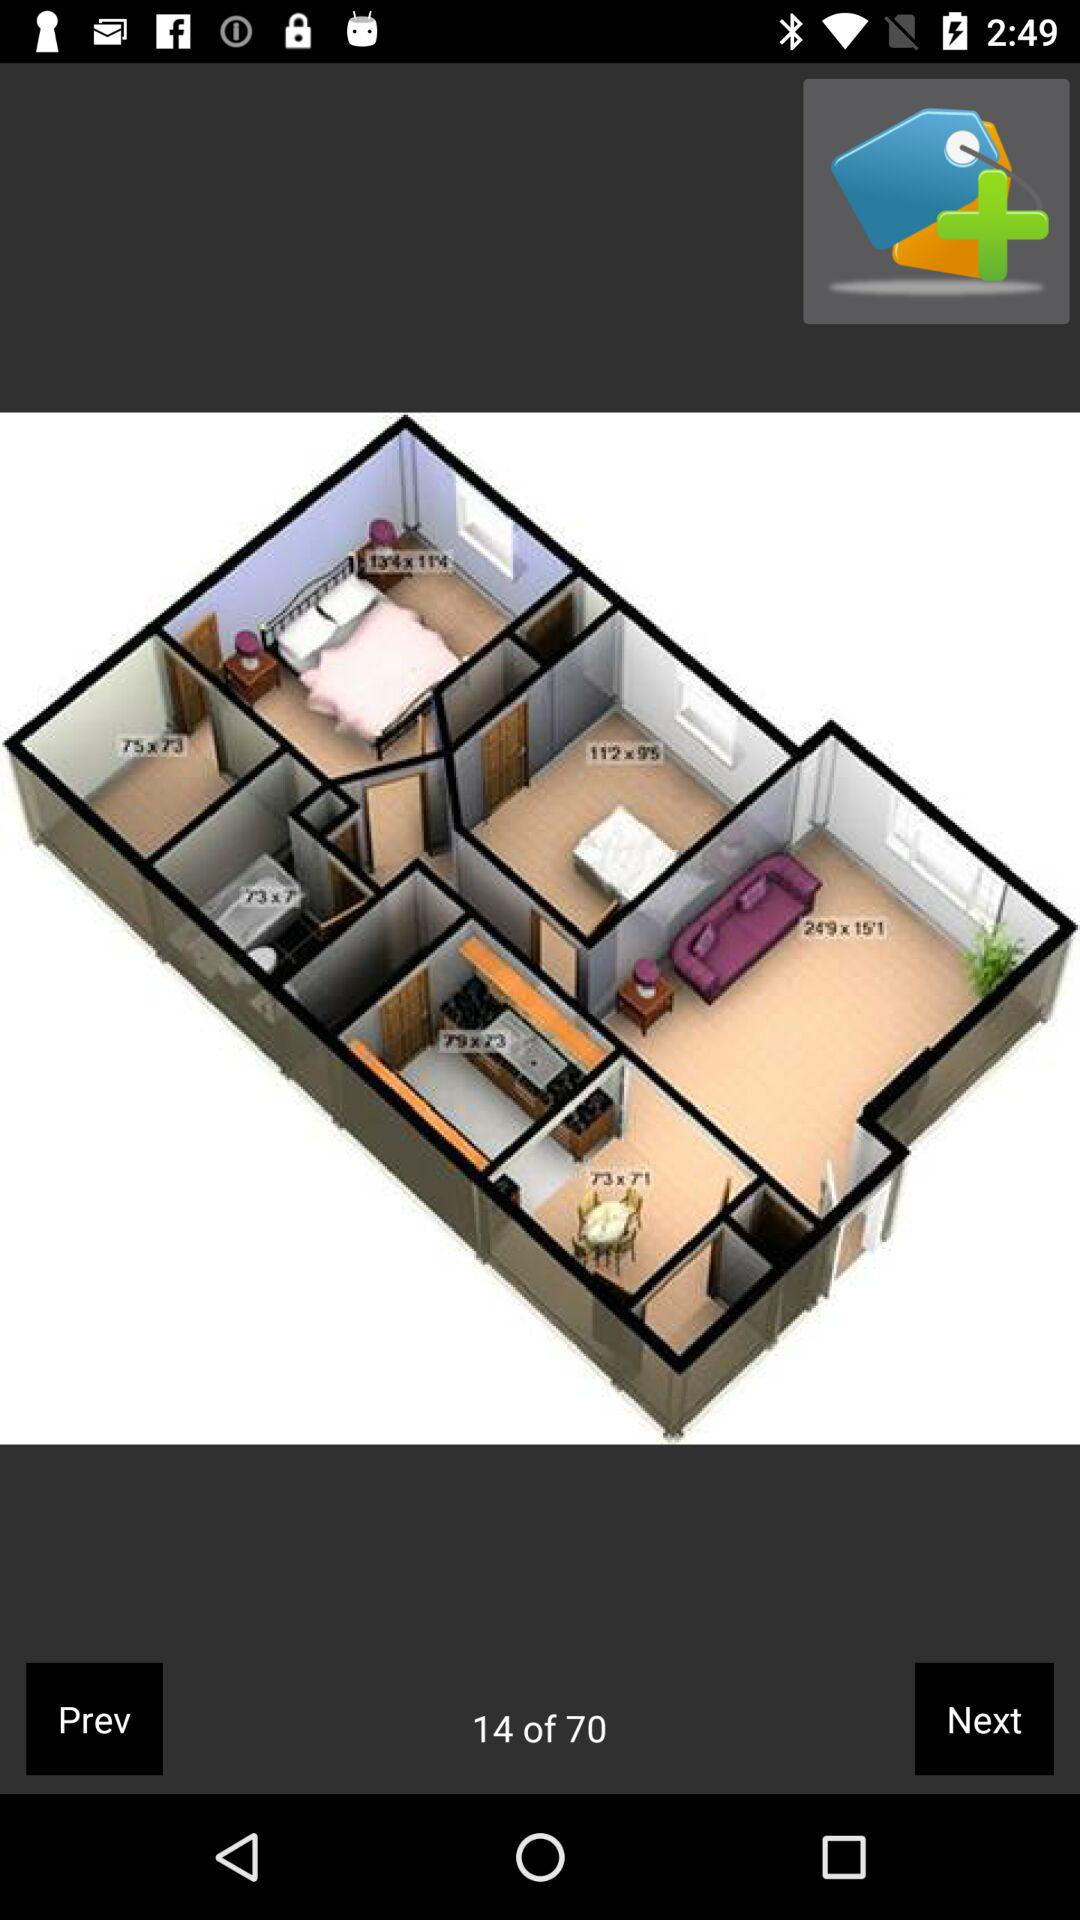What is the number of the current image shown? The number of the current image shown is 14. 